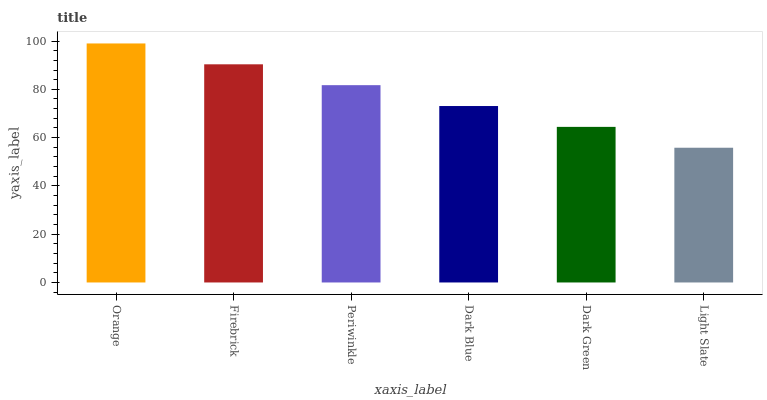Is Firebrick the minimum?
Answer yes or no. No. Is Firebrick the maximum?
Answer yes or no. No. Is Orange greater than Firebrick?
Answer yes or no. Yes. Is Firebrick less than Orange?
Answer yes or no. Yes. Is Firebrick greater than Orange?
Answer yes or no. No. Is Orange less than Firebrick?
Answer yes or no. No. Is Periwinkle the high median?
Answer yes or no. Yes. Is Dark Blue the low median?
Answer yes or no. Yes. Is Dark Blue the high median?
Answer yes or no. No. Is Dark Green the low median?
Answer yes or no. No. 